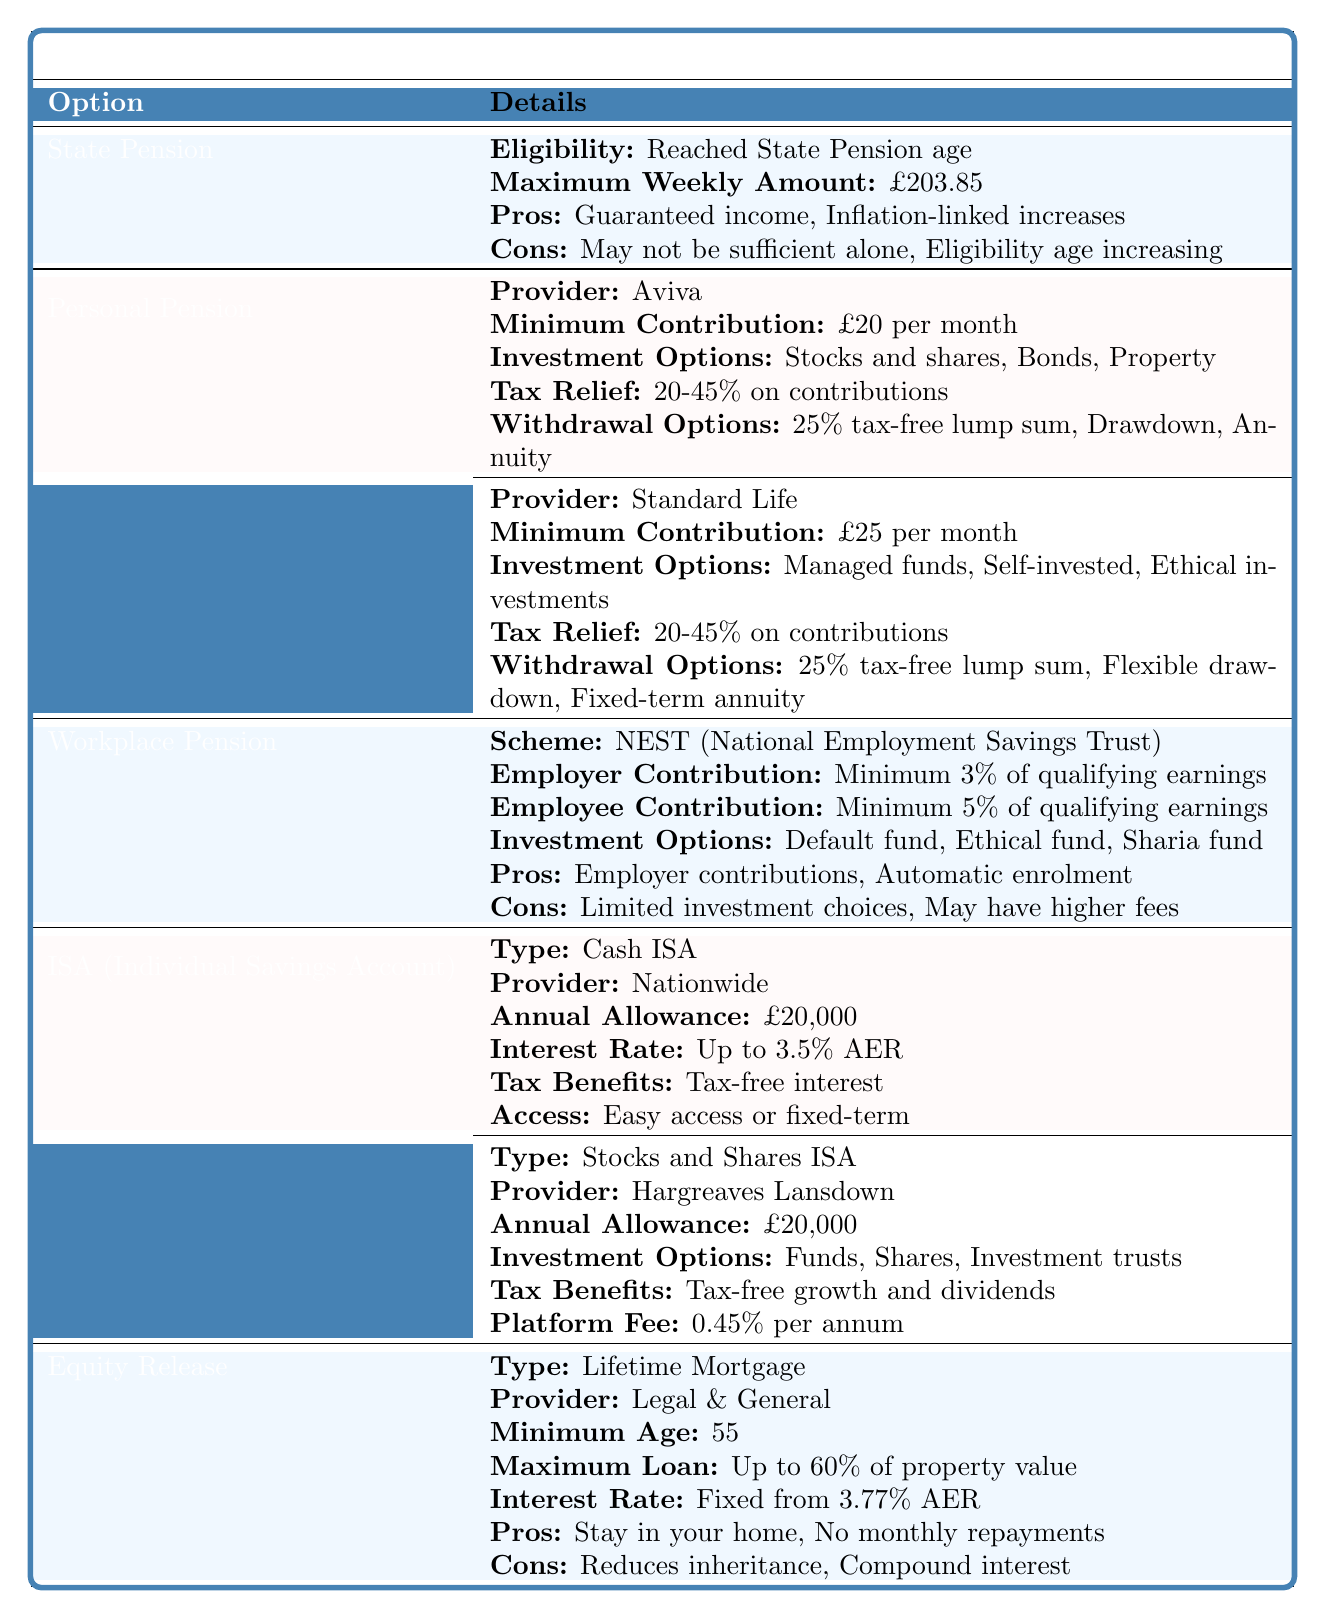What is the maximum weekly amount for the State Pension? The table states that the maximum weekly amount for the State Pension is £203.85.
Answer: £203.85 How much is the minimum contribution for Standard Life’s Personal Pension? According to the table, the minimum contribution for Standard Life is £25 per month.
Answer: £25 per month Is there a tax relief benefit for Personal Pensions? Yes, the table indicates that there is tax relief of 20-45% on contributions for Personal Pensions.
Answer: Yes What are the investment options for the Cash ISA type? The table lists that the Cash ISA provided by Nationwide includes tax-free interest, but does not specify particular investment options. Therefore, the focus is on easy access or fixed-term instead.
Answer: No specific investment options listed What is the minimum age requirement to access Equity Release through a Lifetime Mortgage? The table indicates that the minimum age to access Equity Release via a Lifetime Mortgage is 55.
Answer: 55 Which pension option involves employer contributions? The Workplace Pension option, particularly the NEST scheme as specified in the table, involves employer contributions.
Answer: Workplace Pension If a person chooses a Stocks and Shares ISA, what is the platform fee? The table notes that the platform fee for Hargreaves Lansdown's Stocks and Shares ISA is 0.45% per annum.
Answer: 0.45% per annum How does the maximum loan amount for Equity Release compare to 50% of property value? The maximum loan for Equity Release is up to 60% of property value, which is greater than 50%.
Answer: Greater than What are the withdrawal options for a Personal Pension provided by Aviva? According to the table, the withdrawal options for Aviva’s Personal Pension are a 25% tax-free lump sum, Drawdown, and Annuity.
Answer: 25% tax-free lump sum, Drawdown, Annuity Which retirement savings option offers guaranteed income? The State Pension is the only option listed that provides guaranteed income.
Answer: State Pension Which savings option has the least investment choices according to the table? The Workplace Pension is indicated to have limited investment choices as per the table.
Answer: Workplace Pension 